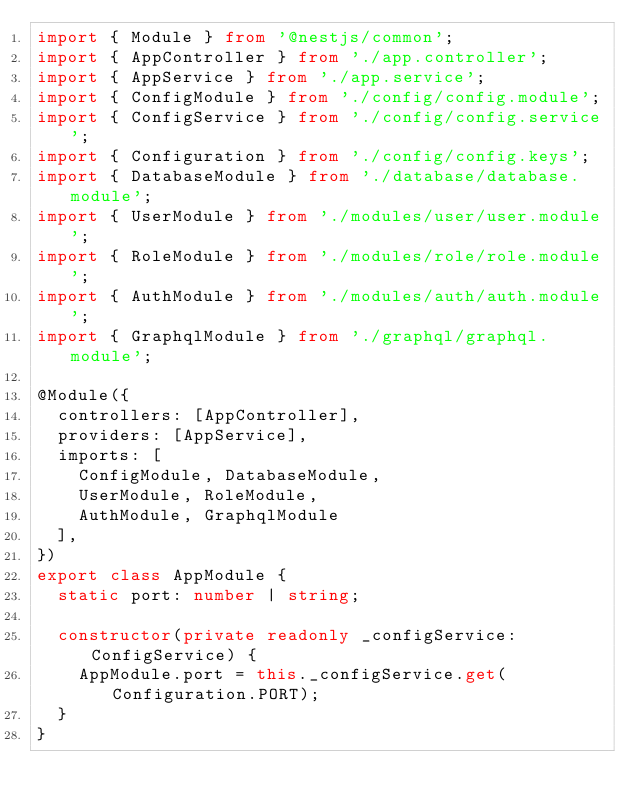Convert code to text. <code><loc_0><loc_0><loc_500><loc_500><_TypeScript_>import { Module } from '@nestjs/common';
import { AppController } from './app.controller';
import { AppService } from './app.service';
import { ConfigModule } from './config/config.module';
import { ConfigService } from './config/config.service';
import { Configuration } from './config/config.keys';
import { DatabaseModule } from './database/database.module';
import { UserModule } from './modules/user/user.module';
import { RoleModule } from './modules/role/role.module';
import { AuthModule } from './modules/auth/auth.module';
import { GraphqlModule } from './graphql/graphql.module';

@Module({
  controllers: [AppController],
  providers: [AppService],
  imports: [
    ConfigModule, DatabaseModule,
    UserModule, RoleModule,
    AuthModule, GraphqlModule
  ],
})
export class AppModule {
  static port: number | string;

  constructor(private readonly _configService: ConfigService) {
    AppModule.port = this._configService.get(Configuration.PORT);
  }
}
</code> 